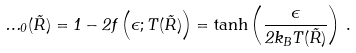<formula> <loc_0><loc_0><loc_500><loc_500>\Phi _ { 0 } ( \vec { R } ) = 1 - 2 f \left ( \epsilon ; T ( \vec { R } ) \right ) = \tanh \left ( \frac { \epsilon } { 2 k _ { B } T ( \vec { R } ) } \right ) \, .</formula> 